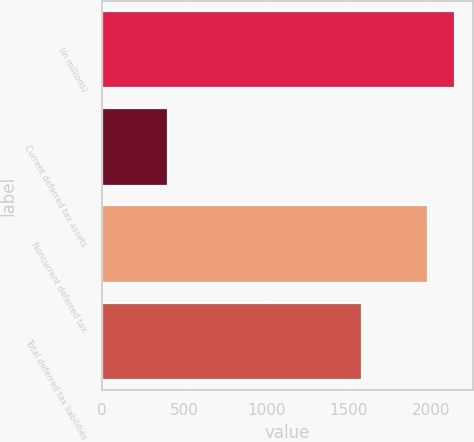Convert chart to OTSL. <chart><loc_0><loc_0><loc_500><loc_500><bar_chart><fcel>(in millions)<fcel>Current deferred tax assets<fcel>Noncurrent deferred tax<fcel>Total deferred tax liabilities<nl><fcel>2141.7<fcel>401<fcel>1981<fcel>1580<nl></chart> 